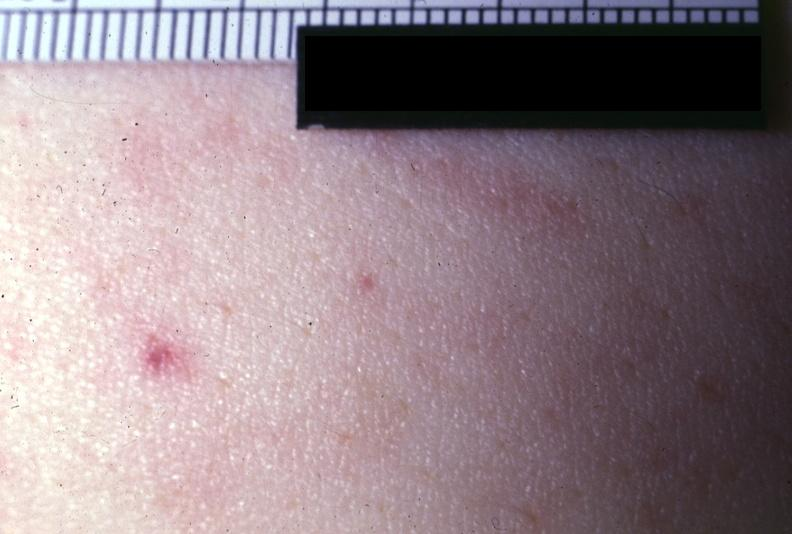where is this?
Answer the question using a single word or phrase. Skin 